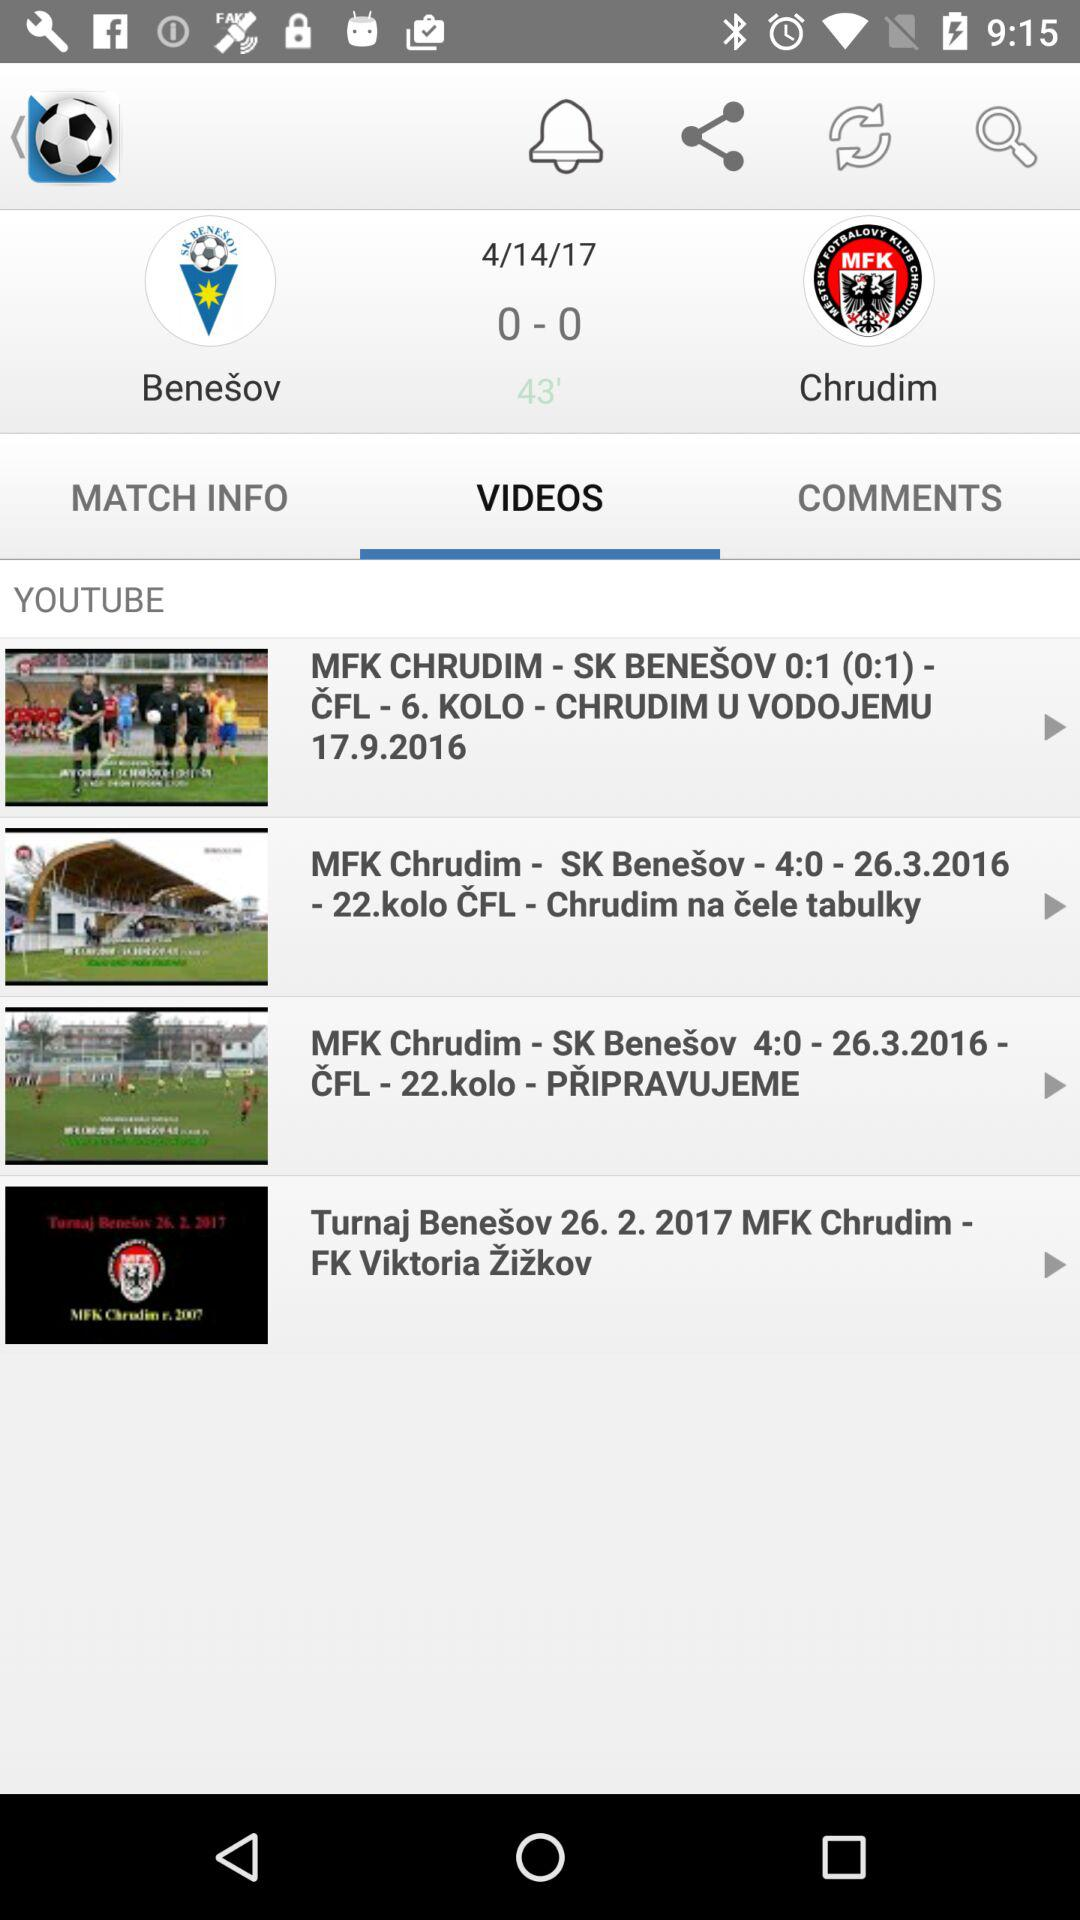On what date was the video posted "MFK CHRUDIM - SK BENEŠOV 0:1 (0:1) - ČFL - 6. KOLO - CHRUDIM U VODOJEMU"? The date was September 17, 2016. 